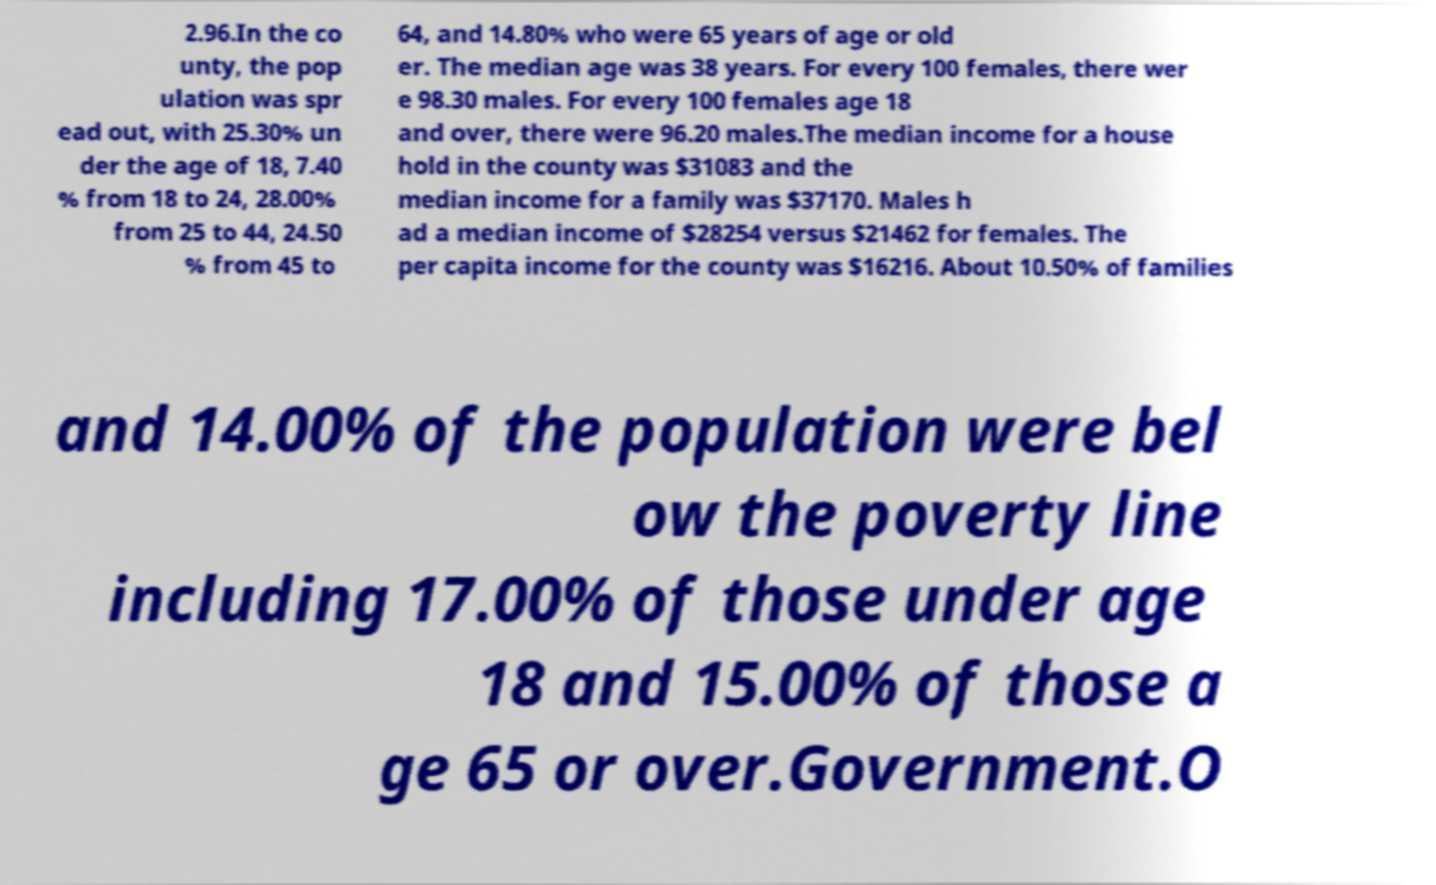For documentation purposes, I need the text within this image transcribed. Could you provide that? 2.96.In the co unty, the pop ulation was spr ead out, with 25.30% un der the age of 18, 7.40 % from 18 to 24, 28.00% from 25 to 44, 24.50 % from 45 to 64, and 14.80% who were 65 years of age or old er. The median age was 38 years. For every 100 females, there wer e 98.30 males. For every 100 females age 18 and over, there were 96.20 males.The median income for a house hold in the county was $31083 and the median income for a family was $37170. Males h ad a median income of $28254 versus $21462 for females. The per capita income for the county was $16216. About 10.50% of families and 14.00% of the population were bel ow the poverty line including 17.00% of those under age 18 and 15.00% of those a ge 65 or over.Government.O 